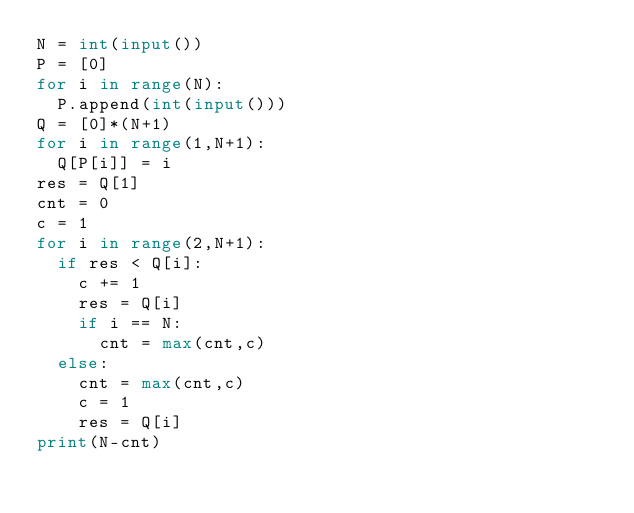<code> <loc_0><loc_0><loc_500><loc_500><_Python_>N = int(input())
P = [0]
for i in range(N):
  P.append(int(input()))
Q = [0]*(N+1)
for i in range(1,N+1):
  Q[P[i]] = i
res = Q[1]
cnt = 0  
c = 1
for i in range(2,N+1):
  if res < Q[i]:
    c += 1
    res = Q[i]
    if i == N:
      cnt = max(cnt,c)
  else:
    cnt = max(cnt,c)
    c = 1
    res = Q[i]
print(N-cnt)      </code> 